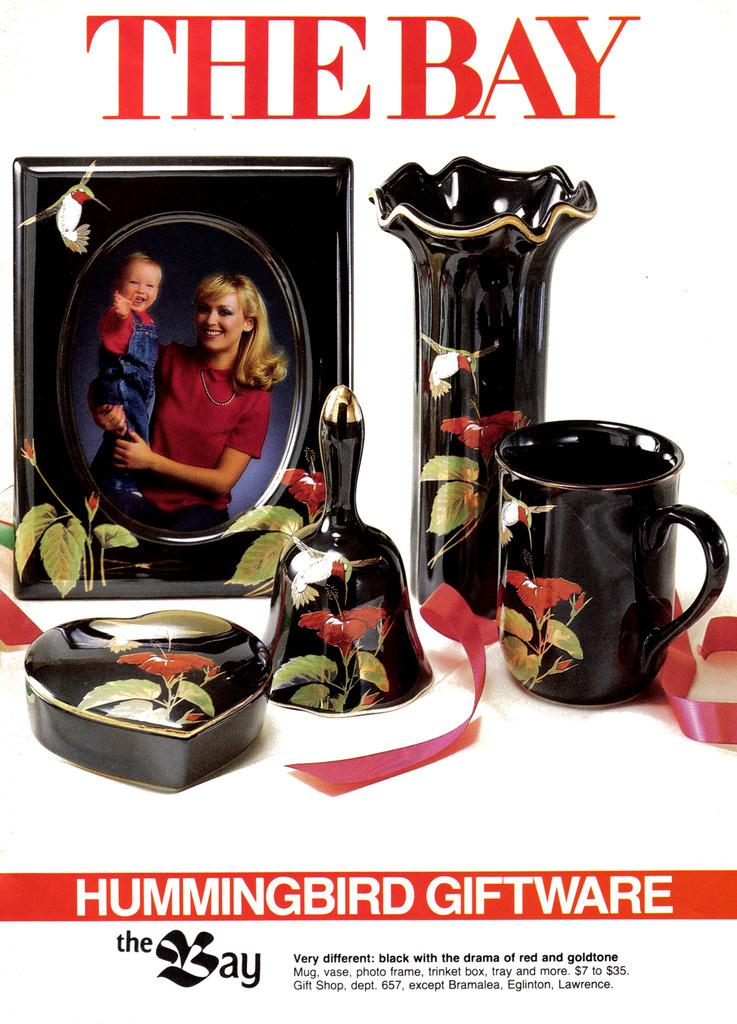<image>
Present a compact description of the photo's key features. a mom and a baby in a frame with the word Bay above them 